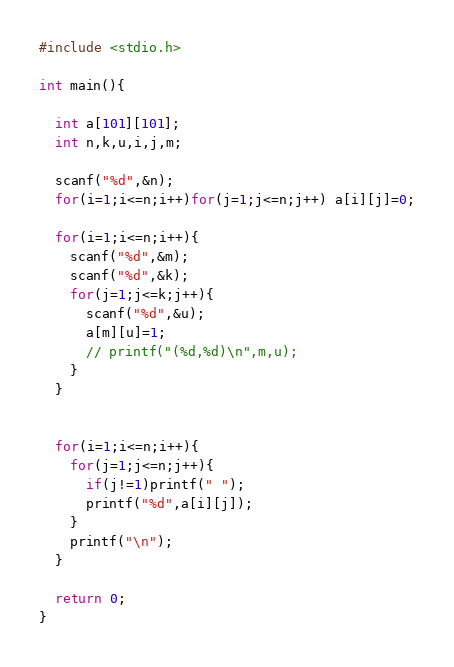<code> <loc_0><loc_0><loc_500><loc_500><_C_>#include <stdio.h>

int main(){

  int a[101][101];
  int n,k,u,i,j,m;

  scanf("%d",&n);
  for(i=1;i<=n;i++)for(j=1;j<=n;j++) a[i][j]=0;

  for(i=1;i<=n;i++){
    scanf("%d",&m);
    scanf("%d",&k);
    for(j=1;j<=k;j++){
      scanf("%d",&u);
      a[m][u]=1;
      // printf("(%d,%d)\n",m,u);
    }
  }


  for(i=1;i<=n;i++){
    for(j=1;j<=n;j++){
      if(j!=1)printf(" ");
      printf("%d",a[i][j]);
    }
    printf("\n");
  }
  
  return 0;
}

</code> 